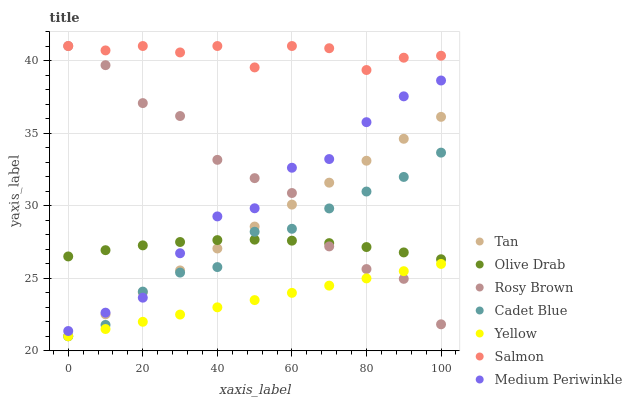Does Yellow have the minimum area under the curve?
Answer yes or no. Yes. Does Salmon have the maximum area under the curve?
Answer yes or no. Yes. Does Medium Periwinkle have the minimum area under the curve?
Answer yes or no. No. Does Medium Periwinkle have the maximum area under the curve?
Answer yes or no. No. Is Yellow the smoothest?
Answer yes or no. Yes. Is Rosy Brown the roughest?
Answer yes or no. Yes. Is Medium Periwinkle the smoothest?
Answer yes or no. No. Is Medium Periwinkle the roughest?
Answer yes or no. No. Does Cadet Blue have the lowest value?
Answer yes or no. Yes. Does Medium Periwinkle have the lowest value?
Answer yes or no. No. Does Salmon have the highest value?
Answer yes or no. Yes. Does Medium Periwinkle have the highest value?
Answer yes or no. No. Is Yellow less than Salmon?
Answer yes or no. Yes. Is Olive Drab greater than Yellow?
Answer yes or no. Yes. Does Cadet Blue intersect Olive Drab?
Answer yes or no. Yes. Is Cadet Blue less than Olive Drab?
Answer yes or no. No. Is Cadet Blue greater than Olive Drab?
Answer yes or no. No. Does Yellow intersect Salmon?
Answer yes or no. No. 